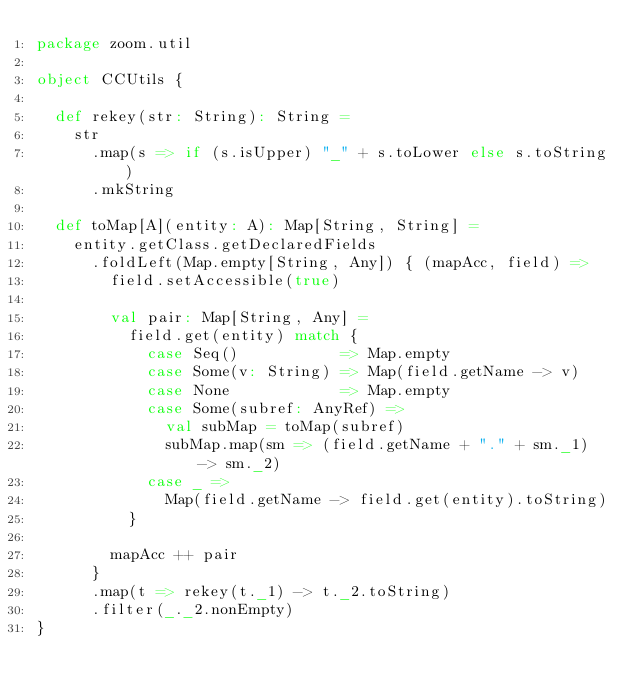Convert code to text. <code><loc_0><loc_0><loc_500><loc_500><_Scala_>package zoom.util

object CCUtils {

  def rekey(str: String): String =
    str
      .map(s => if (s.isUpper) "_" + s.toLower else s.toString)
      .mkString

  def toMap[A](entity: A): Map[String, String] =
    entity.getClass.getDeclaredFields
      .foldLeft(Map.empty[String, Any]) { (mapAcc, field) =>
        field.setAccessible(true)

        val pair: Map[String, Any] =
          field.get(entity) match {
            case Seq()           => Map.empty
            case Some(v: String) => Map(field.getName -> v)
            case None            => Map.empty
            case Some(subref: AnyRef) =>
              val subMap = toMap(subref)
              subMap.map(sm => (field.getName + "." + sm._1) -> sm._2)
            case _ =>
              Map(field.getName -> field.get(entity).toString)
          }

        mapAcc ++ pair
      }
      .map(t => rekey(t._1) -> t._2.toString)
      .filter(_._2.nonEmpty)
}
</code> 